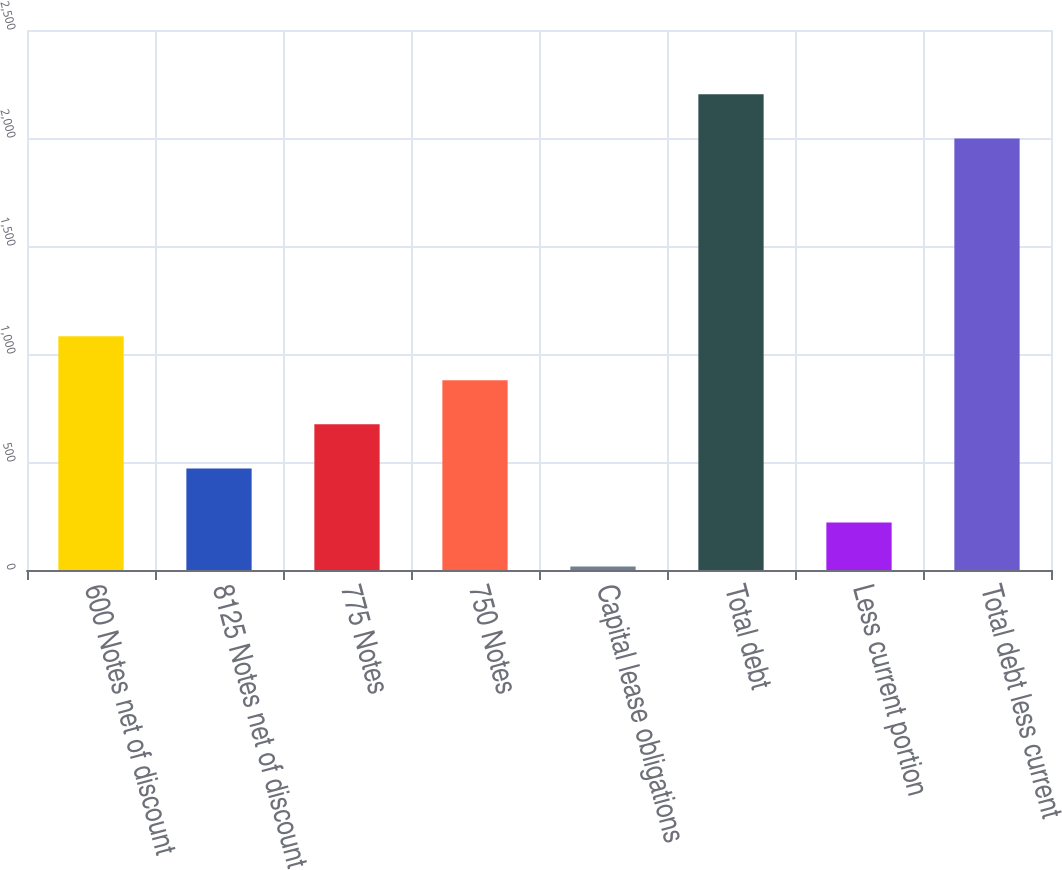Convert chart to OTSL. <chart><loc_0><loc_0><loc_500><loc_500><bar_chart><fcel>600 Notes net of discount<fcel>8125 Notes net of discount<fcel>775 Notes<fcel>750 Notes<fcel>Capital lease obligations<fcel>Total debt<fcel>Less current portion<fcel>Total debt less current<nl><fcel>1082.6<fcel>470<fcel>674.2<fcel>878.4<fcel>16<fcel>2202.2<fcel>220.2<fcel>1998<nl></chart> 